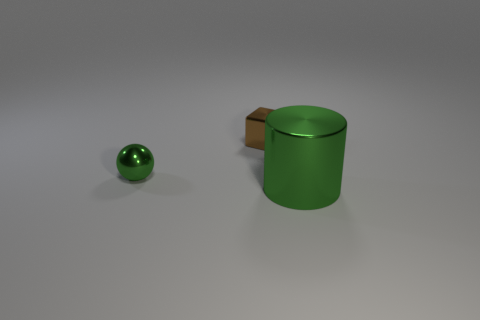Add 3 green blocks. How many objects exist? 6 Subtract all cylinders. How many objects are left? 2 Subtract 0 red cylinders. How many objects are left? 3 Subtract all small brown matte balls. Subtract all brown metal cubes. How many objects are left? 2 Add 3 metallic objects. How many metallic objects are left? 6 Add 1 small cylinders. How many small cylinders exist? 1 